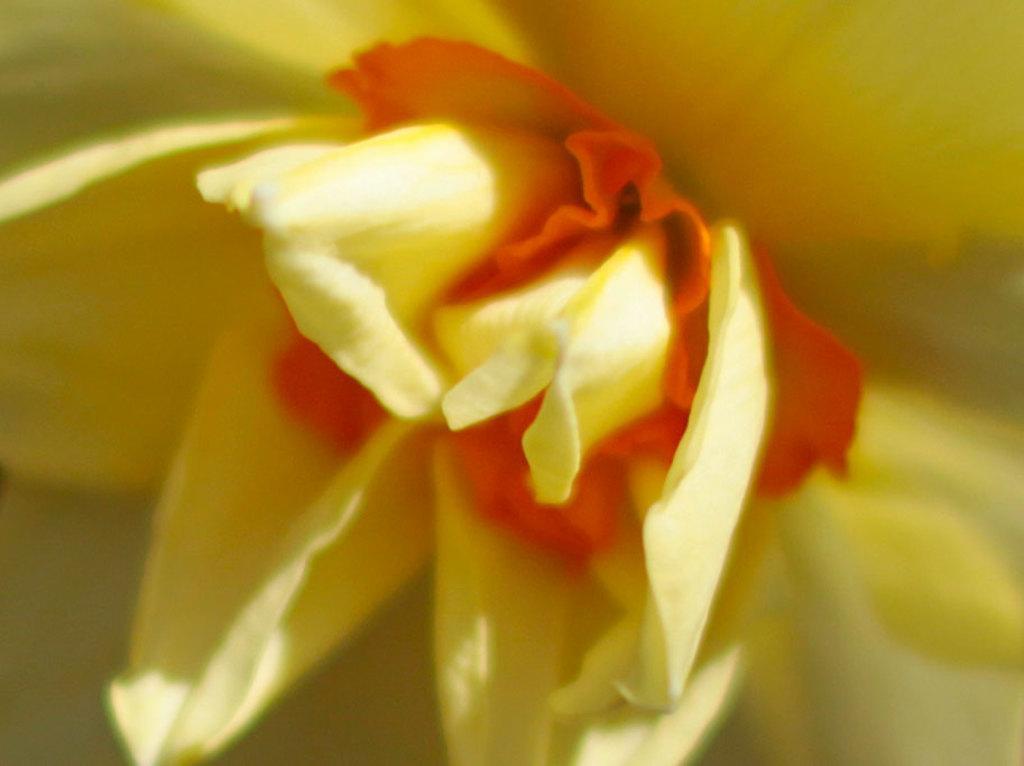Could you give a brief overview of what you see in this image? In this picture I can see a flower. 